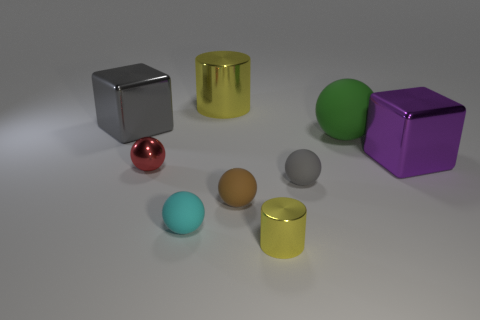There is a green ball that is the same size as the purple block; what is its material?
Make the answer very short. Rubber. Are the large yellow object and the gray block made of the same material?
Offer a terse response. Yes. How many big yellow things are made of the same material as the small brown ball?
Keep it short and to the point. 0. How many objects are either large things right of the big gray shiny thing or small yellow cylinders in front of the large green sphere?
Offer a terse response. 4. Are there more metallic things that are left of the green ball than tiny metal things to the right of the red metal thing?
Your answer should be compact. Yes. There is a big metal object that is to the left of the big yellow thing; what color is it?
Your answer should be compact. Gray. Is there a small gray object that has the same shape as the large yellow thing?
Make the answer very short. No. What number of yellow objects are blocks or big metal objects?
Ensure brevity in your answer.  1. Are there any gray spheres that have the same size as the cyan rubber object?
Your response must be concise. Yes. How many gray objects are there?
Your answer should be very brief. 2. 